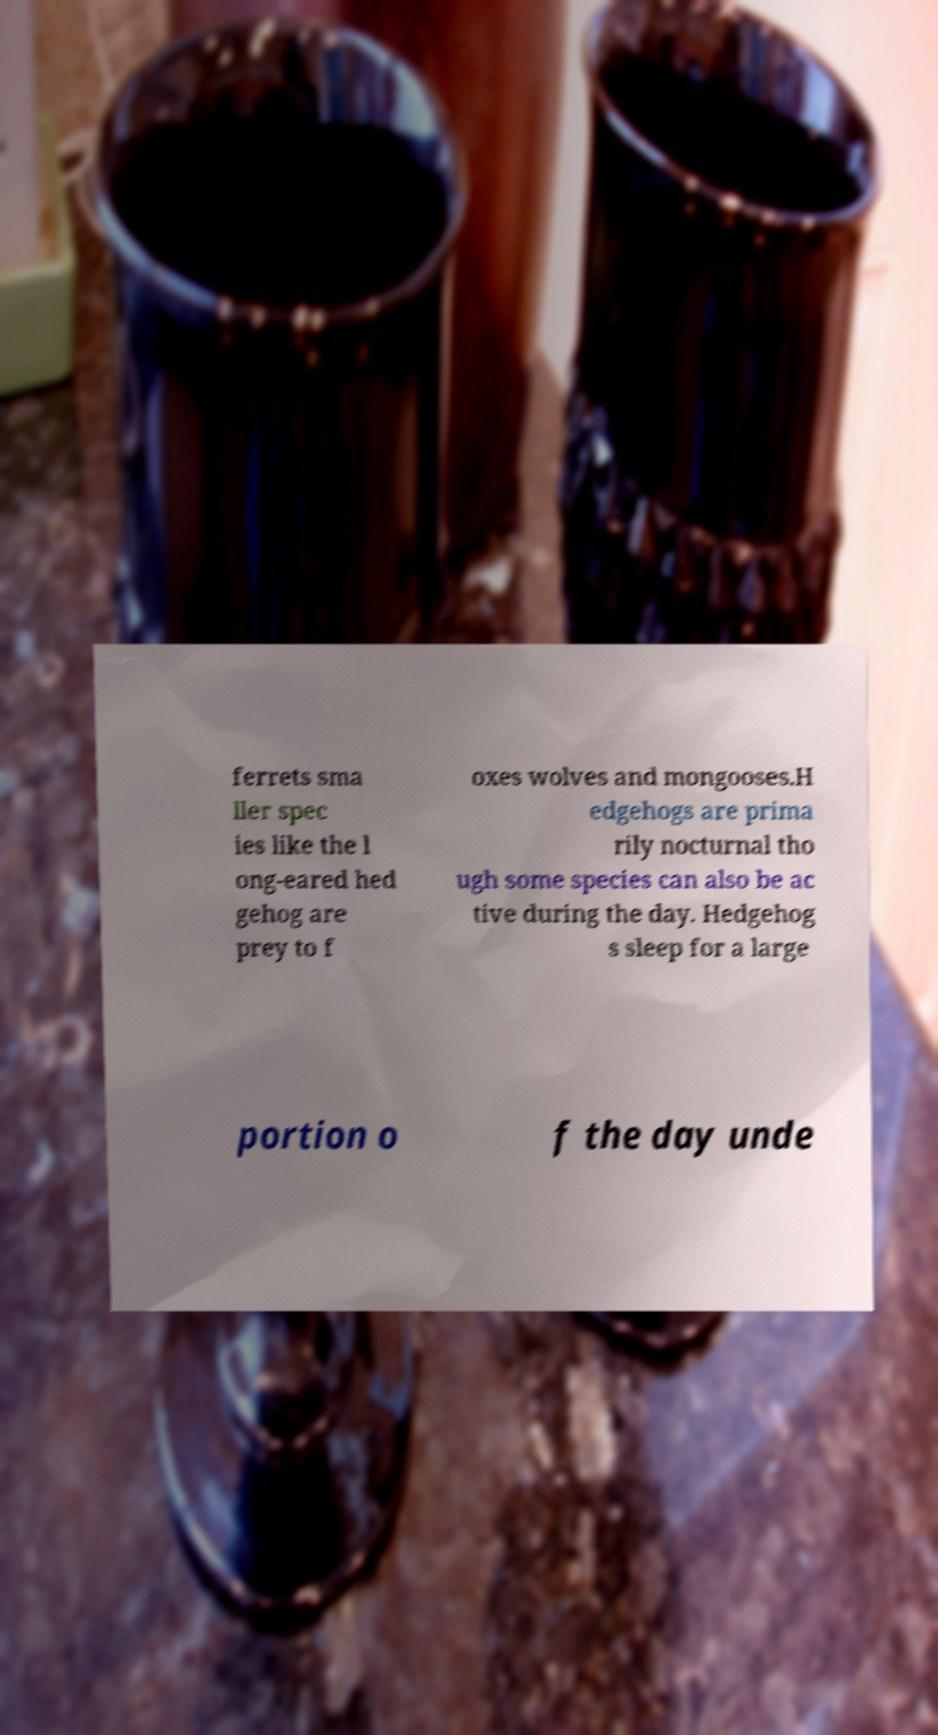I need the written content from this picture converted into text. Can you do that? ferrets sma ller spec ies like the l ong-eared hed gehog are prey to f oxes wolves and mongooses.H edgehogs are prima rily nocturnal tho ugh some species can also be ac tive during the day. Hedgehog s sleep for a large portion o f the day unde 